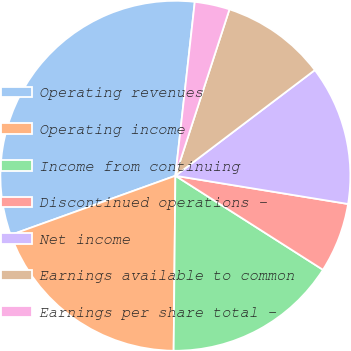<chart> <loc_0><loc_0><loc_500><loc_500><pie_chart><fcel>Operating revenues<fcel>Operating income<fcel>Income from continuing<fcel>Discontinued operations -<fcel>Net income<fcel>Earnings available to common<fcel>Earnings per share total -<nl><fcel>32.26%<fcel>19.35%<fcel>16.13%<fcel>6.45%<fcel>12.9%<fcel>9.68%<fcel>3.23%<nl></chart> 